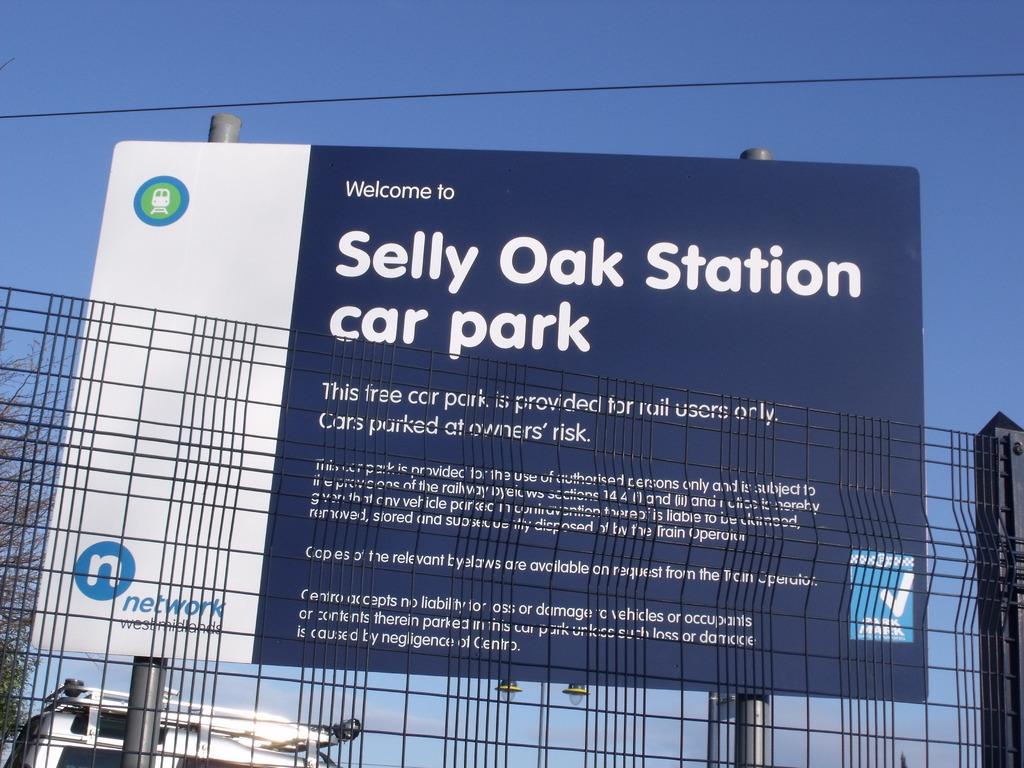What station car park is here?
Your answer should be compact. Selly oak. What can you park at selly oak station?
Your answer should be very brief. Car. 